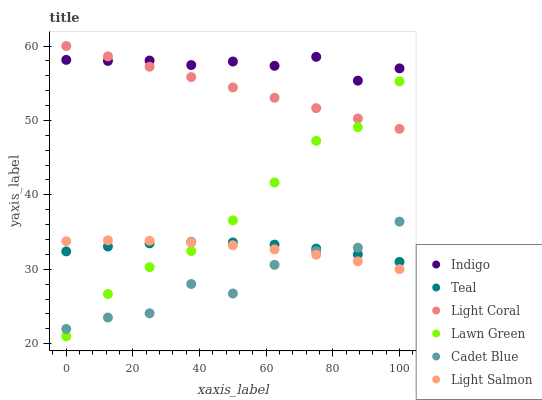Does Cadet Blue have the minimum area under the curve?
Answer yes or no. Yes. Does Indigo have the maximum area under the curve?
Answer yes or no. Yes. Does Light Salmon have the minimum area under the curve?
Answer yes or no. No. Does Light Salmon have the maximum area under the curve?
Answer yes or no. No. Is Light Coral the smoothest?
Answer yes or no. Yes. Is Cadet Blue the roughest?
Answer yes or no. Yes. Is Light Salmon the smoothest?
Answer yes or no. No. Is Light Salmon the roughest?
Answer yes or no. No. Does Lawn Green have the lowest value?
Answer yes or no. Yes. Does Light Salmon have the lowest value?
Answer yes or no. No. Does Light Coral have the highest value?
Answer yes or no. Yes. Does Light Salmon have the highest value?
Answer yes or no. No. Is Light Salmon less than Light Coral?
Answer yes or no. Yes. Is Indigo greater than Cadet Blue?
Answer yes or no. Yes. Does Teal intersect Cadet Blue?
Answer yes or no. Yes. Is Teal less than Cadet Blue?
Answer yes or no. No. Is Teal greater than Cadet Blue?
Answer yes or no. No. Does Light Salmon intersect Light Coral?
Answer yes or no. No. 